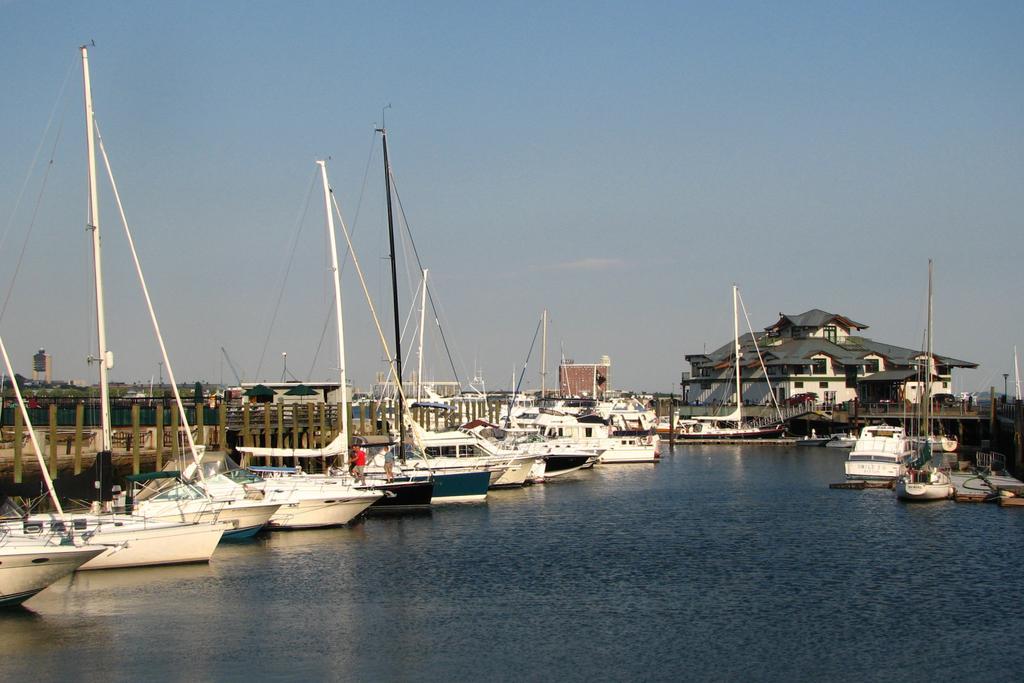Describe this image in one or two sentences. There are ships on the water. Behind that there is fencing and buildings. 